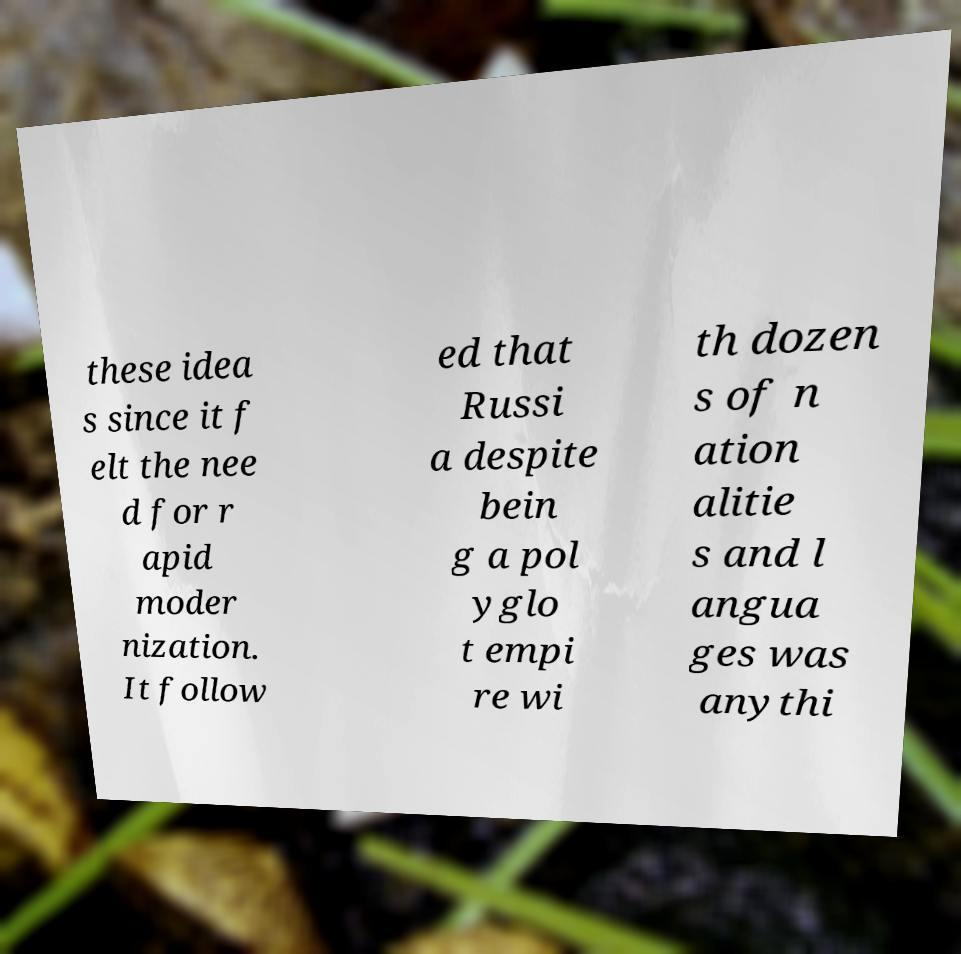There's text embedded in this image that I need extracted. Can you transcribe it verbatim? these idea s since it f elt the nee d for r apid moder nization. It follow ed that Russi a despite bein g a pol yglo t empi re wi th dozen s of n ation alitie s and l angua ges was anythi 